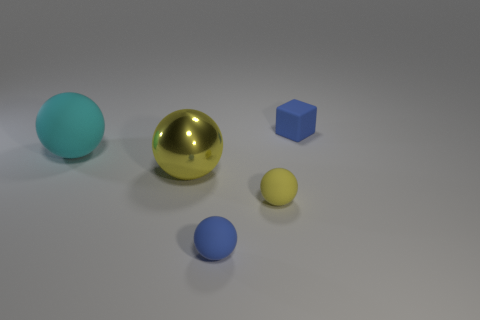Add 4 tiny blue things. How many objects exist? 9 Subtract all blocks. How many objects are left? 4 Add 2 big spheres. How many big spheres are left? 4 Add 1 big rubber spheres. How many big rubber spheres exist? 2 Subtract 0 brown blocks. How many objects are left? 5 Subtract all gray matte things. Subtract all small rubber blocks. How many objects are left? 4 